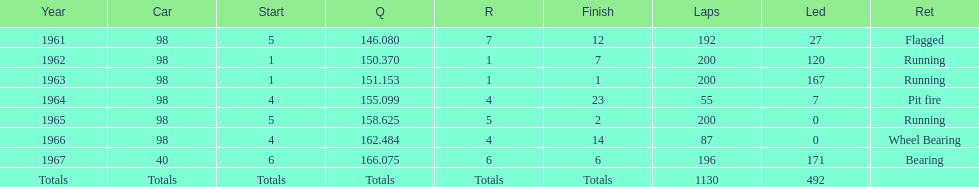How many total laps have been driven in the indy 500? 1130. 